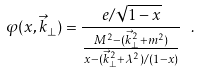<formula> <loc_0><loc_0><loc_500><loc_500>\varphi ( x , { \vec { k } } _ { \perp } ) = \frac { e / \sqrt { 1 - x } } { \frac { M ^ { 2 } - ( { \vec { k } } _ { \perp } ^ { 2 } + m ^ { 2 } ) } { x - ( { \vec { k } } _ { \perp } ^ { 2 } + \lambda ^ { 2 } ) / ( 1 - x ) } } \ .</formula> 